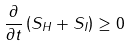<formula> <loc_0><loc_0><loc_500><loc_500>\frac { \partial } { \partial t } \left ( S _ { H } + S _ { I } \right ) \geq 0</formula> 